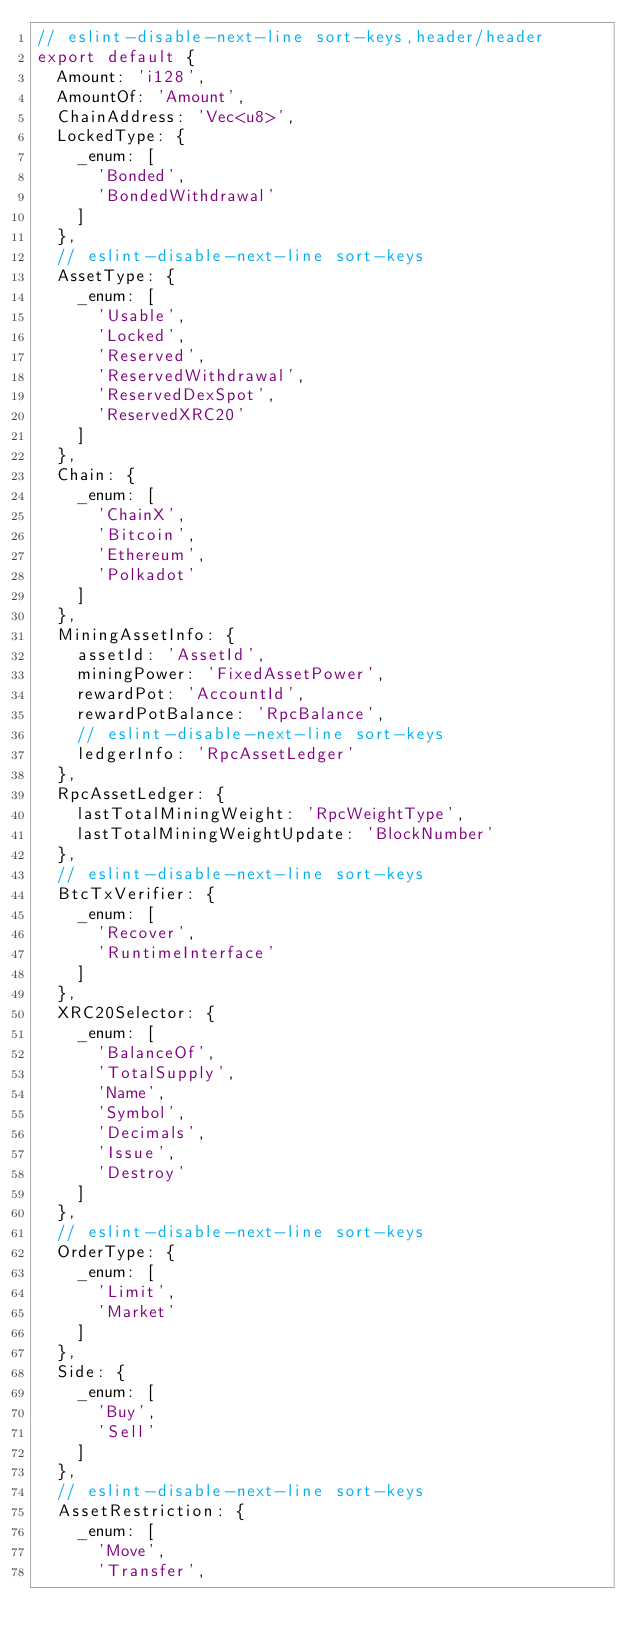Convert code to text. <code><loc_0><loc_0><loc_500><loc_500><_TypeScript_>// eslint-disable-next-line sort-keys,header/header
export default {
  Amount: 'i128',
  AmountOf: 'Amount',
  ChainAddress: 'Vec<u8>',
  LockedType: {
    _enum: [
      'Bonded',
      'BondedWithdrawal'
    ]
  },
  // eslint-disable-next-line sort-keys
  AssetType: {
    _enum: [
      'Usable',
      'Locked',
      'Reserved',
      'ReservedWithdrawal',
      'ReservedDexSpot',
      'ReservedXRC20'
    ]
  },
  Chain: {
    _enum: [
      'ChainX',
      'Bitcoin',
      'Ethereum',
      'Polkadot'
    ]
  },
  MiningAssetInfo: {
    assetId: 'AssetId',
    miningPower: 'FixedAssetPower',
    rewardPot: 'AccountId',
    rewardPotBalance: 'RpcBalance',
    // eslint-disable-next-line sort-keys
    ledgerInfo: 'RpcAssetLedger'
  },
  RpcAssetLedger: {
    lastTotalMiningWeight: 'RpcWeightType',
    lastTotalMiningWeightUpdate: 'BlockNumber'
  },
  // eslint-disable-next-line sort-keys
  BtcTxVerifier: {
    _enum: [
      'Recover',
      'RuntimeInterface'
    ]
  },
  XRC20Selector: {
    _enum: [
      'BalanceOf',
      'TotalSupply',
      'Name',
      'Symbol',
      'Decimals',
      'Issue',
      'Destroy'
    ]
  },
  // eslint-disable-next-line sort-keys
  OrderType: {
    _enum: [
      'Limit',
      'Market'
    ]
  },
  Side: {
    _enum: [
      'Buy',
      'Sell'
    ]
  },
  // eslint-disable-next-line sort-keys
  AssetRestriction: {
    _enum: [
      'Move',
      'Transfer',</code> 